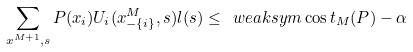<formula> <loc_0><loc_0><loc_500><loc_500>\sum _ { x ^ { M + 1 } , s } P ( x _ { i } ) U _ { i } ( x ^ { M } _ { - \{ i \} } , s ) l ( s ) \leq \ w e a k s y m \cos t _ { M } ( P ) - \alpha</formula> 